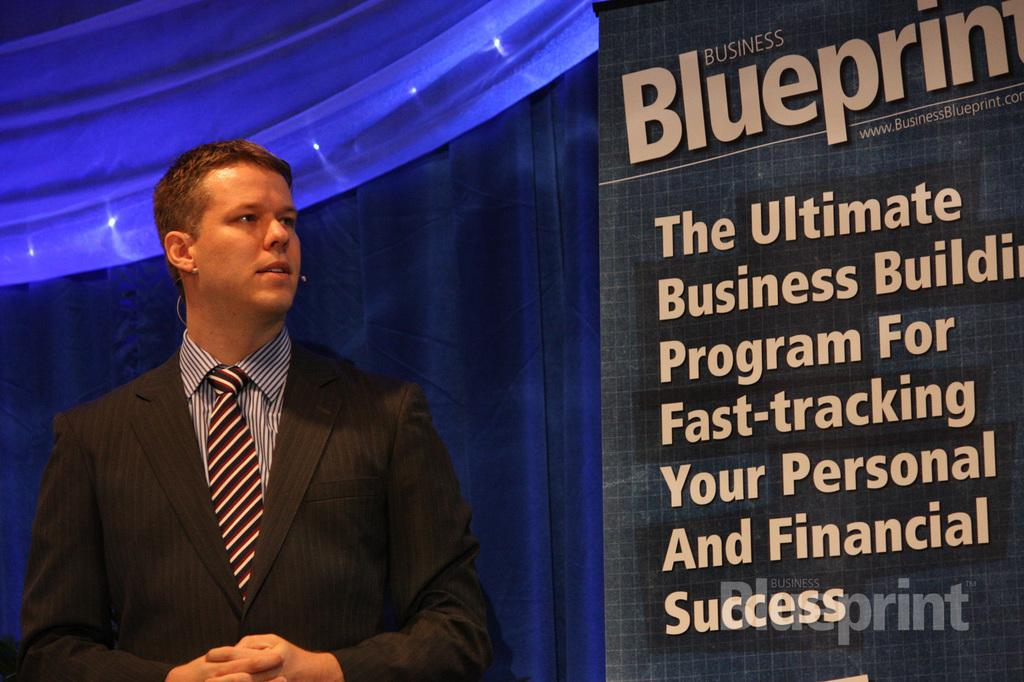What is the person in the image wearing? The person is wearing a suit in the image. Where is the person located in the image? The person is on the left side of the image. What is displayed on the screen in the image? There is a screen with text in the image. Where is the screen located in the image? The screen is on the right side of the image. What can be seen in the background of the image? There is a curtain in the background of the image. What type of stew is being prepared on the range in the image? There is no range or stew present in the image. What time of day is it during the dinner scene in the image? There is no dinner scene or indication of time of day in the image. 